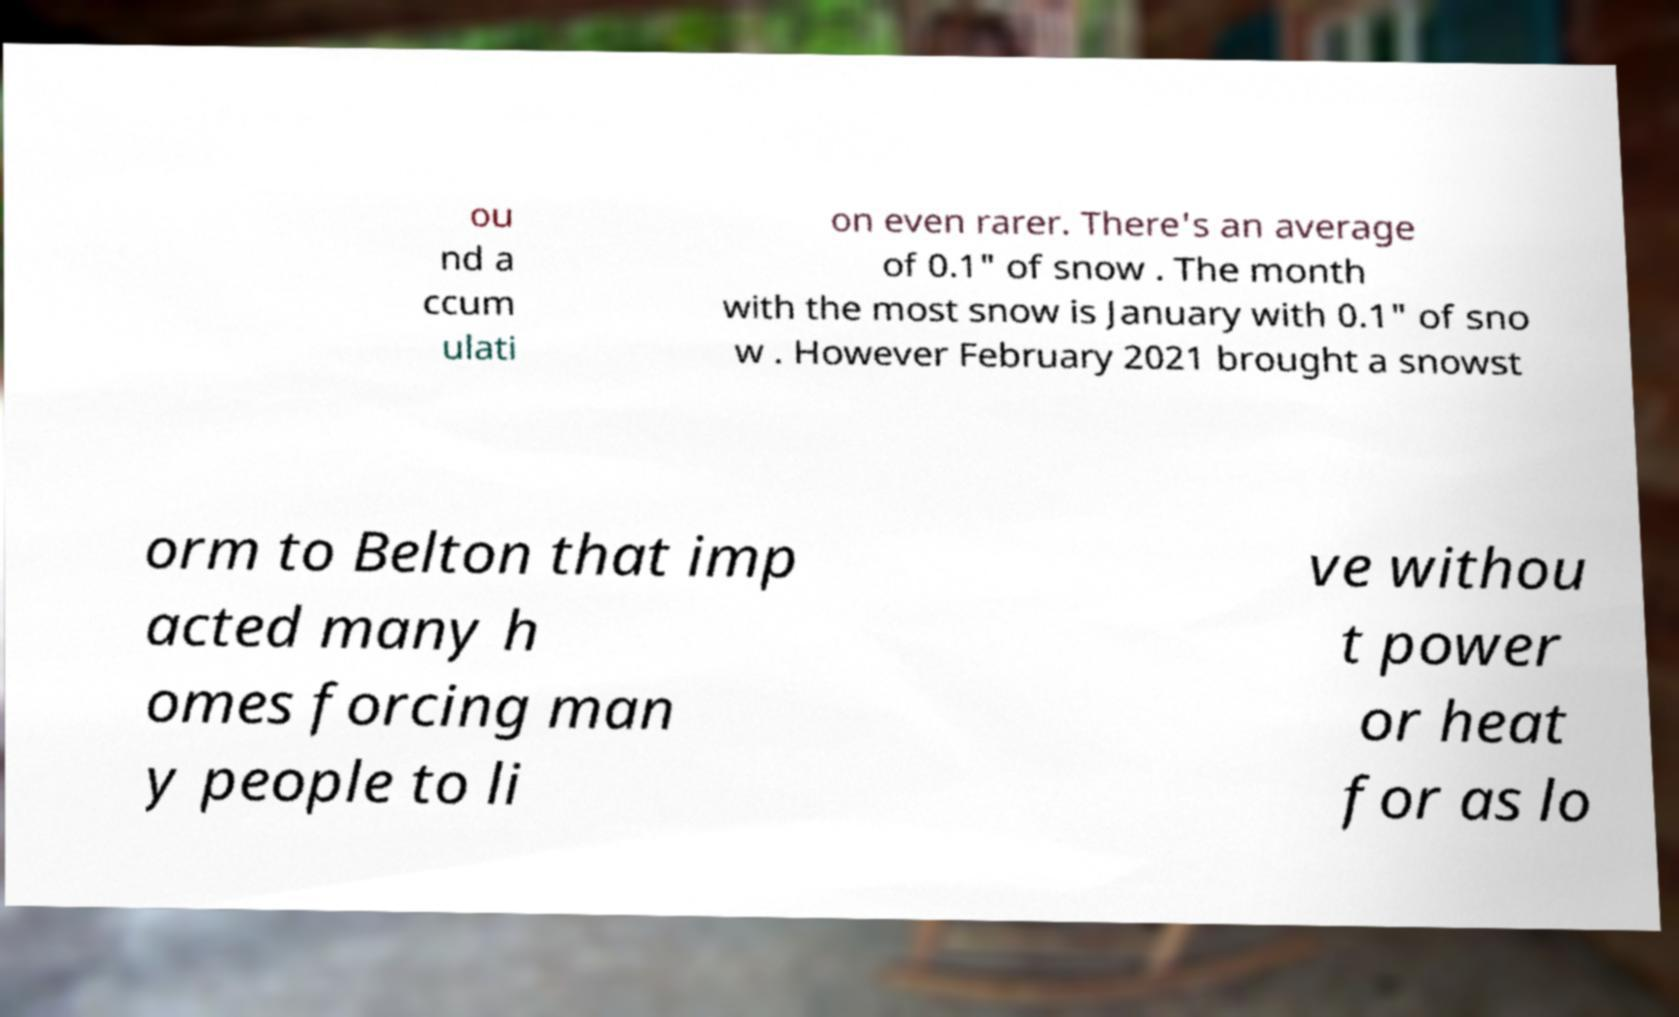For documentation purposes, I need the text within this image transcribed. Could you provide that? ou nd a ccum ulati on even rarer. There's an average of 0.1" of snow . The month with the most snow is January with 0.1" of sno w . However February 2021 brought a snowst orm to Belton that imp acted many h omes forcing man y people to li ve withou t power or heat for as lo 